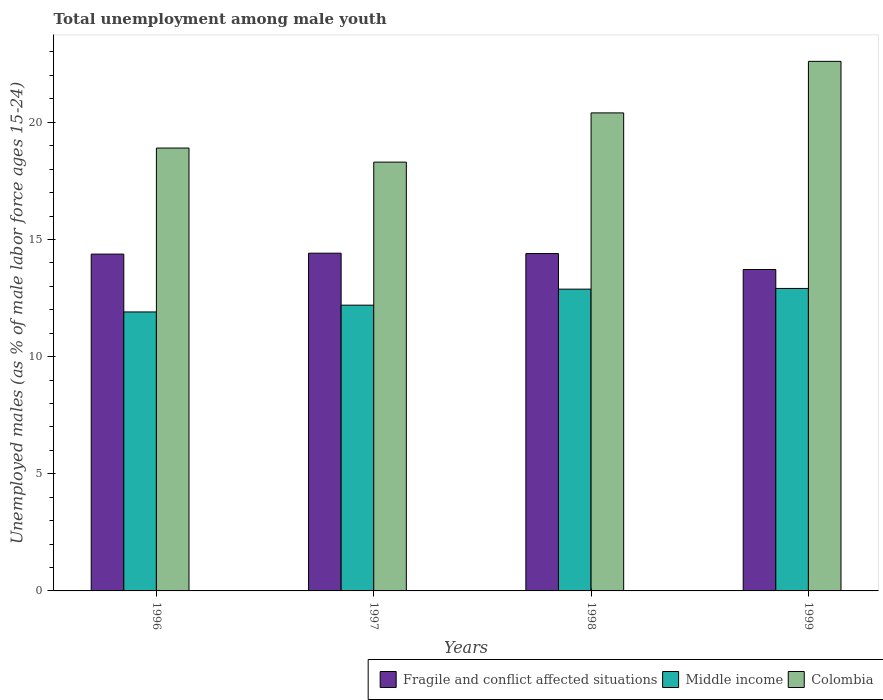Are the number of bars per tick equal to the number of legend labels?
Your answer should be very brief. Yes. Are the number of bars on each tick of the X-axis equal?
Your answer should be compact. Yes. How many bars are there on the 2nd tick from the left?
Make the answer very short. 3. What is the label of the 4th group of bars from the left?
Ensure brevity in your answer.  1999. In how many cases, is the number of bars for a given year not equal to the number of legend labels?
Make the answer very short. 0. What is the percentage of unemployed males in in Colombia in 1997?
Provide a succinct answer. 18.3. Across all years, what is the maximum percentage of unemployed males in in Colombia?
Provide a short and direct response. 22.6. Across all years, what is the minimum percentage of unemployed males in in Fragile and conflict affected situations?
Keep it short and to the point. 13.72. In which year was the percentage of unemployed males in in Fragile and conflict affected situations maximum?
Provide a short and direct response. 1997. What is the total percentage of unemployed males in in Middle income in the graph?
Your response must be concise. 49.89. What is the difference between the percentage of unemployed males in in Middle income in 1996 and that in 1998?
Your response must be concise. -0.97. What is the difference between the percentage of unemployed males in in Middle income in 1997 and the percentage of unemployed males in in Colombia in 1996?
Your response must be concise. -6.7. What is the average percentage of unemployed males in in Fragile and conflict affected situations per year?
Provide a succinct answer. 14.23. In the year 1996, what is the difference between the percentage of unemployed males in in Middle income and percentage of unemployed males in in Colombia?
Ensure brevity in your answer.  -6.99. What is the ratio of the percentage of unemployed males in in Colombia in 1996 to that in 1998?
Offer a terse response. 0.93. Is the percentage of unemployed males in in Fragile and conflict affected situations in 1998 less than that in 1999?
Your answer should be compact. No. What is the difference between the highest and the second highest percentage of unemployed males in in Middle income?
Make the answer very short. 0.03. What is the difference between the highest and the lowest percentage of unemployed males in in Fragile and conflict affected situations?
Your answer should be compact. 0.7. In how many years, is the percentage of unemployed males in in Fragile and conflict affected situations greater than the average percentage of unemployed males in in Fragile and conflict affected situations taken over all years?
Your response must be concise. 3. What does the 3rd bar from the right in 1999 represents?
Your answer should be compact. Fragile and conflict affected situations. Is it the case that in every year, the sum of the percentage of unemployed males in in Fragile and conflict affected situations and percentage of unemployed males in in Middle income is greater than the percentage of unemployed males in in Colombia?
Your answer should be very brief. Yes. How many bars are there?
Provide a short and direct response. 12. What is the difference between two consecutive major ticks on the Y-axis?
Your answer should be very brief. 5. Does the graph contain grids?
Offer a very short reply. No. What is the title of the graph?
Ensure brevity in your answer.  Total unemployment among male youth. What is the label or title of the Y-axis?
Ensure brevity in your answer.  Unemployed males (as % of male labor force ages 15-24). What is the Unemployed males (as % of male labor force ages 15-24) of Fragile and conflict affected situations in 1996?
Offer a very short reply. 14.37. What is the Unemployed males (as % of male labor force ages 15-24) in Middle income in 1996?
Your answer should be very brief. 11.91. What is the Unemployed males (as % of male labor force ages 15-24) in Colombia in 1996?
Your answer should be compact. 18.9. What is the Unemployed males (as % of male labor force ages 15-24) in Fragile and conflict affected situations in 1997?
Give a very brief answer. 14.41. What is the Unemployed males (as % of male labor force ages 15-24) in Middle income in 1997?
Make the answer very short. 12.2. What is the Unemployed males (as % of male labor force ages 15-24) in Colombia in 1997?
Offer a terse response. 18.3. What is the Unemployed males (as % of male labor force ages 15-24) of Fragile and conflict affected situations in 1998?
Your answer should be very brief. 14.4. What is the Unemployed males (as % of male labor force ages 15-24) of Middle income in 1998?
Your response must be concise. 12.88. What is the Unemployed males (as % of male labor force ages 15-24) of Colombia in 1998?
Make the answer very short. 20.4. What is the Unemployed males (as % of male labor force ages 15-24) of Fragile and conflict affected situations in 1999?
Your answer should be compact. 13.72. What is the Unemployed males (as % of male labor force ages 15-24) in Middle income in 1999?
Provide a short and direct response. 12.91. What is the Unemployed males (as % of male labor force ages 15-24) of Colombia in 1999?
Ensure brevity in your answer.  22.6. Across all years, what is the maximum Unemployed males (as % of male labor force ages 15-24) in Fragile and conflict affected situations?
Offer a terse response. 14.41. Across all years, what is the maximum Unemployed males (as % of male labor force ages 15-24) in Middle income?
Make the answer very short. 12.91. Across all years, what is the maximum Unemployed males (as % of male labor force ages 15-24) of Colombia?
Offer a very short reply. 22.6. Across all years, what is the minimum Unemployed males (as % of male labor force ages 15-24) in Fragile and conflict affected situations?
Your answer should be very brief. 13.72. Across all years, what is the minimum Unemployed males (as % of male labor force ages 15-24) in Middle income?
Ensure brevity in your answer.  11.91. Across all years, what is the minimum Unemployed males (as % of male labor force ages 15-24) in Colombia?
Keep it short and to the point. 18.3. What is the total Unemployed males (as % of male labor force ages 15-24) in Fragile and conflict affected situations in the graph?
Ensure brevity in your answer.  56.9. What is the total Unemployed males (as % of male labor force ages 15-24) of Middle income in the graph?
Your response must be concise. 49.89. What is the total Unemployed males (as % of male labor force ages 15-24) of Colombia in the graph?
Keep it short and to the point. 80.2. What is the difference between the Unemployed males (as % of male labor force ages 15-24) in Fragile and conflict affected situations in 1996 and that in 1997?
Your answer should be compact. -0.04. What is the difference between the Unemployed males (as % of male labor force ages 15-24) in Middle income in 1996 and that in 1997?
Ensure brevity in your answer.  -0.29. What is the difference between the Unemployed males (as % of male labor force ages 15-24) of Fragile and conflict affected situations in 1996 and that in 1998?
Your answer should be very brief. -0.02. What is the difference between the Unemployed males (as % of male labor force ages 15-24) of Middle income in 1996 and that in 1998?
Your response must be concise. -0.97. What is the difference between the Unemployed males (as % of male labor force ages 15-24) in Fragile and conflict affected situations in 1996 and that in 1999?
Keep it short and to the point. 0.66. What is the difference between the Unemployed males (as % of male labor force ages 15-24) of Middle income in 1996 and that in 1999?
Your answer should be compact. -1. What is the difference between the Unemployed males (as % of male labor force ages 15-24) in Colombia in 1996 and that in 1999?
Provide a succinct answer. -3.7. What is the difference between the Unemployed males (as % of male labor force ages 15-24) of Fragile and conflict affected situations in 1997 and that in 1998?
Your answer should be very brief. 0.02. What is the difference between the Unemployed males (as % of male labor force ages 15-24) of Middle income in 1997 and that in 1998?
Keep it short and to the point. -0.68. What is the difference between the Unemployed males (as % of male labor force ages 15-24) of Colombia in 1997 and that in 1998?
Your answer should be very brief. -2.1. What is the difference between the Unemployed males (as % of male labor force ages 15-24) in Fragile and conflict affected situations in 1997 and that in 1999?
Your response must be concise. 0.7. What is the difference between the Unemployed males (as % of male labor force ages 15-24) in Middle income in 1997 and that in 1999?
Your response must be concise. -0.71. What is the difference between the Unemployed males (as % of male labor force ages 15-24) of Colombia in 1997 and that in 1999?
Provide a succinct answer. -4.3. What is the difference between the Unemployed males (as % of male labor force ages 15-24) of Fragile and conflict affected situations in 1998 and that in 1999?
Your response must be concise. 0.68. What is the difference between the Unemployed males (as % of male labor force ages 15-24) in Middle income in 1998 and that in 1999?
Your response must be concise. -0.03. What is the difference between the Unemployed males (as % of male labor force ages 15-24) of Fragile and conflict affected situations in 1996 and the Unemployed males (as % of male labor force ages 15-24) of Middle income in 1997?
Make the answer very short. 2.18. What is the difference between the Unemployed males (as % of male labor force ages 15-24) in Fragile and conflict affected situations in 1996 and the Unemployed males (as % of male labor force ages 15-24) in Colombia in 1997?
Provide a succinct answer. -3.93. What is the difference between the Unemployed males (as % of male labor force ages 15-24) of Middle income in 1996 and the Unemployed males (as % of male labor force ages 15-24) of Colombia in 1997?
Your answer should be compact. -6.39. What is the difference between the Unemployed males (as % of male labor force ages 15-24) of Fragile and conflict affected situations in 1996 and the Unemployed males (as % of male labor force ages 15-24) of Middle income in 1998?
Your response must be concise. 1.5. What is the difference between the Unemployed males (as % of male labor force ages 15-24) of Fragile and conflict affected situations in 1996 and the Unemployed males (as % of male labor force ages 15-24) of Colombia in 1998?
Provide a short and direct response. -6.03. What is the difference between the Unemployed males (as % of male labor force ages 15-24) of Middle income in 1996 and the Unemployed males (as % of male labor force ages 15-24) of Colombia in 1998?
Offer a terse response. -8.49. What is the difference between the Unemployed males (as % of male labor force ages 15-24) of Fragile and conflict affected situations in 1996 and the Unemployed males (as % of male labor force ages 15-24) of Middle income in 1999?
Give a very brief answer. 1.47. What is the difference between the Unemployed males (as % of male labor force ages 15-24) in Fragile and conflict affected situations in 1996 and the Unemployed males (as % of male labor force ages 15-24) in Colombia in 1999?
Your answer should be very brief. -8.23. What is the difference between the Unemployed males (as % of male labor force ages 15-24) of Middle income in 1996 and the Unemployed males (as % of male labor force ages 15-24) of Colombia in 1999?
Your response must be concise. -10.69. What is the difference between the Unemployed males (as % of male labor force ages 15-24) in Fragile and conflict affected situations in 1997 and the Unemployed males (as % of male labor force ages 15-24) in Middle income in 1998?
Give a very brief answer. 1.53. What is the difference between the Unemployed males (as % of male labor force ages 15-24) of Fragile and conflict affected situations in 1997 and the Unemployed males (as % of male labor force ages 15-24) of Colombia in 1998?
Offer a very short reply. -5.99. What is the difference between the Unemployed males (as % of male labor force ages 15-24) in Middle income in 1997 and the Unemployed males (as % of male labor force ages 15-24) in Colombia in 1998?
Keep it short and to the point. -8.2. What is the difference between the Unemployed males (as % of male labor force ages 15-24) of Fragile and conflict affected situations in 1997 and the Unemployed males (as % of male labor force ages 15-24) of Middle income in 1999?
Your response must be concise. 1.5. What is the difference between the Unemployed males (as % of male labor force ages 15-24) in Fragile and conflict affected situations in 1997 and the Unemployed males (as % of male labor force ages 15-24) in Colombia in 1999?
Ensure brevity in your answer.  -8.19. What is the difference between the Unemployed males (as % of male labor force ages 15-24) in Middle income in 1997 and the Unemployed males (as % of male labor force ages 15-24) in Colombia in 1999?
Make the answer very short. -10.4. What is the difference between the Unemployed males (as % of male labor force ages 15-24) of Fragile and conflict affected situations in 1998 and the Unemployed males (as % of male labor force ages 15-24) of Middle income in 1999?
Your response must be concise. 1.49. What is the difference between the Unemployed males (as % of male labor force ages 15-24) in Fragile and conflict affected situations in 1998 and the Unemployed males (as % of male labor force ages 15-24) in Colombia in 1999?
Your response must be concise. -8.2. What is the difference between the Unemployed males (as % of male labor force ages 15-24) of Middle income in 1998 and the Unemployed males (as % of male labor force ages 15-24) of Colombia in 1999?
Make the answer very short. -9.72. What is the average Unemployed males (as % of male labor force ages 15-24) of Fragile and conflict affected situations per year?
Your answer should be very brief. 14.23. What is the average Unemployed males (as % of male labor force ages 15-24) in Middle income per year?
Your answer should be compact. 12.47. What is the average Unemployed males (as % of male labor force ages 15-24) in Colombia per year?
Provide a succinct answer. 20.05. In the year 1996, what is the difference between the Unemployed males (as % of male labor force ages 15-24) in Fragile and conflict affected situations and Unemployed males (as % of male labor force ages 15-24) in Middle income?
Offer a terse response. 2.47. In the year 1996, what is the difference between the Unemployed males (as % of male labor force ages 15-24) in Fragile and conflict affected situations and Unemployed males (as % of male labor force ages 15-24) in Colombia?
Ensure brevity in your answer.  -4.53. In the year 1996, what is the difference between the Unemployed males (as % of male labor force ages 15-24) of Middle income and Unemployed males (as % of male labor force ages 15-24) of Colombia?
Make the answer very short. -6.99. In the year 1997, what is the difference between the Unemployed males (as % of male labor force ages 15-24) of Fragile and conflict affected situations and Unemployed males (as % of male labor force ages 15-24) of Middle income?
Ensure brevity in your answer.  2.22. In the year 1997, what is the difference between the Unemployed males (as % of male labor force ages 15-24) of Fragile and conflict affected situations and Unemployed males (as % of male labor force ages 15-24) of Colombia?
Your answer should be compact. -3.89. In the year 1997, what is the difference between the Unemployed males (as % of male labor force ages 15-24) of Middle income and Unemployed males (as % of male labor force ages 15-24) of Colombia?
Provide a short and direct response. -6.1. In the year 1998, what is the difference between the Unemployed males (as % of male labor force ages 15-24) of Fragile and conflict affected situations and Unemployed males (as % of male labor force ages 15-24) of Middle income?
Offer a terse response. 1.52. In the year 1998, what is the difference between the Unemployed males (as % of male labor force ages 15-24) in Fragile and conflict affected situations and Unemployed males (as % of male labor force ages 15-24) in Colombia?
Give a very brief answer. -6. In the year 1998, what is the difference between the Unemployed males (as % of male labor force ages 15-24) in Middle income and Unemployed males (as % of male labor force ages 15-24) in Colombia?
Provide a short and direct response. -7.52. In the year 1999, what is the difference between the Unemployed males (as % of male labor force ages 15-24) of Fragile and conflict affected situations and Unemployed males (as % of male labor force ages 15-24) of Middle income?
Offer a terse response. 0.81. In the year 1999, what is the difference between the Unemployed males (as % of male labor force ages 15-24) in Fragile and conflict affected situations and Unemployed males (as % of male labor force ages 15-24) in Colombia?
Your answer should be compact. -8.88. In the year 1999, what is the difference between the Unemployed males (as % of male labor force ages 15-24) in Middle income and Unemployed males (as % of male labor force ages 15-24) in Colombia?
Your answer should be very brief. -9.69. What is the ratio of the Unemployed males (as % of male labor force ages 15-24) in Fragile and conflict affected situations in 1996 to that in 1997?
Offer a terse response. 1. What is the ratio of the Unemployed males (as % of male labor force ages 15-24) of Middle income in 1996 to that in 1997?
Provide a succinct answer. 0.98. What is the ratio of the Unemployed males (as % of male labor force ages 15-24) in Colombia in 1996 to that in 1997?
Keep it short and to the point. 1.03. What is the ratio of the Unemployed males (as % of male labor force ages 15-24) of Middle income in 1996 to that in 1998?
Make the answer very short. 0.92. What is the ratio of the Unemployed males (as % of male labor force ages 15-24) of Colombia in 1996 to that in 1998?
Provide a succinct answer. 0.93. What is the ratio of the Unemployed males (as % of male labor force ages 15-24) of Fragile and conflict affected situations in 1996 to that in 1999?
Your answer should be compact. 1.05. What is the ratio of the Unemployed males (as % of male labor force ages 15-24) in Middle income in 1996 to that in 1999?
Ensure brevity in your answer.  0.92. What is the ratio of the Unemployed males (as % of male labor force ages 15-24) in Colombia in 1996 to that in 1999?
Ensure brevity in your answer.  0.84. What is the ratio of the Unemployed males (as % of male labor force ages 15-24) of Middle income in 1997 to that in 1998?
Provide a succinct answer. 0.95. What is the ratio of the Unemployed males (as % of male labor force ages 15-24) of Colombia in 1997 to that in 1998?
Offer a terse response. 0.9. What is the ratio of the Unemployed males (as % of male labor force ages 15-24) of Fragile and conflict affected situations in 1997 to that in 1999?
Your response must be concise. 1.05. What is the ratio of the Unemployed males (as % of male labor force ages 15-24) in Middle income in 1997 to that in 1999?
Make the answer very short. 0.94. What is the ratio of the Unemployed males (as % of male labor force ages 15-24) of Colombia in 1997 to that in 1999?
Offer a terse response. 0.81. What is the ratio of the Unemployed males (as % of male labor force ages 15-24) in Fragile and conflict affected situations in 1998 to that in 1999?
Offer a very short reply. 1.05. What is the ratio of the Unemployed males (as % of male labor force ages 15-24) of Colombia in 1998 to that in 1999?
Provide a succinct answer. 0.9. What is the difference between the highest and the second highest Unemployed males (as % of male labor force ages 15-24) of Fragile and conflict affected situations?
Keep it short and to the point. 0.02. What is the difference between the highest and the second highest Unemployed males (as % of male labor force ages 15-24) in Middle income?
Your answer should be very brief. 0.03. What is the difference between the highest and the lowest Unemployed males (as % of male labor force ages 15-24) in Fragile and conflict affected situations?
Your answer should be compact. 0.7. What is the difference between the highest and the lowest Unemployed males (as % of male labor force ages 15-24) in Middle income?
Keep it short and to the point. 1. What is the difference between the highest and the lowest Unemployed males (as % of male labor force ages 15-24) in Colombia?
Offer a very short reply. 4.3. 